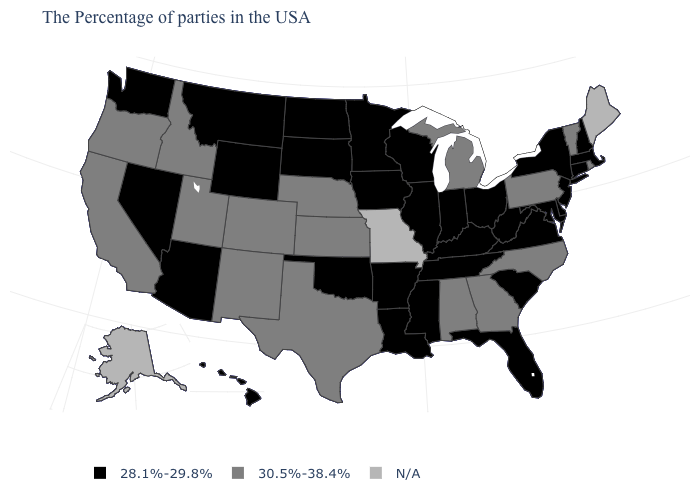What is the value of New York?
Keep it brief. 28.1%-29.8%. What is the value of Mississippi?
Short answer required. 28.1%-29.8%. Name the states that have a value in the range 28.1%-29.8%?
Answer briefly. Massachusetts, New Hampshire, Connecticut, New York, New Jersey, Delaware, Maryland, Virginia, South Carolina, West Virginia, Ohio, Florida, Kentucky, Indiana, Tennessee, Wisconsin, Illinois, Mississippi, Louisiana, Arkansas, Minnesota, Iowa, Oklahoma, South Dakota, North Dakota, Wyoming, Montana, Arizona, Nevada, Washington, Hawaii. Does the first symbol in the legend represent the smallest category?
Keep it brief. Yes. What is the value of Massachusetts?
Keep it brief. 28.1%-29.8%. Which states have the lowest value in the USA?
Write a very short answer. Massachusetts, New Hampshire, Connecticut, New York, New Jersey, Delaware, Maryland, Virginia, South Carolina, West Virginia, Ohio, Florida, Kentucky, Indiana, Tennessee, Wisconsin, Illinois, Mississippi, Louisiana, Arkansas, Minnesota, Iowa, Oklahoma, South Dakota, North Dakota, Wyoming, Montana, Arizona, Nevada, Washington, Hawaii. What is the value of Hawaii?
Quick response, please. 28.1%-29.8%. How many symbols are there in the legend?
Answer briefly. 3. Name the states that have a value in the range 30.5%-38.4%?
Concise answer only. Rhode Island, Vermont, Pennsylvania, North Carolina, Georgia, Michigan, Alabama, Kansas, Nebraska, Texas, Colorado, New Mexico, Utah, Idaho, California, Oregon. Name the states that have a value in the range 28.1%-29.8%?
Answer briefly. Massachusetts, New Hampshire, Connecticut, New York, New Jersey, Delaware, Maryland, Virginia, South Carolina, West Virginia, Ohio, Florida, Kentucky, Indiana, Tennessee, Wisconsin, Illinois, Mississippi, Louisiana, Arkansas, Minnesota, Iowa, Oklahoma, South Dakota, North Dakota, Wyoming, Montana, Arizona, Nevada, Washington, Hawaii. What is the value of Pennsylvania?
Concise answer only. 30.5%-38.4%. Which states have the highest value in the USA?
Write a very short answer. Rhode Island, Vermont, Pennsylvania, North Carolina, Georgia, Michigan, Alabama, Kansas, Nebraska, Texas, Colorado, New Mexico, Utah, Idaho, California, Oregon. Name the states that have a value in the range 28.1%-29.8%?
Quick response, please. Massachusetts, New Hampshire, Connecticut, New York, New Jersey, Delaware, Maryland, Virginia, South Carolina, West Virginia, Ohio, Florida, Kentucky, Indiana, Tennessee, Wisconsin, Illinois, Mississippi, Louisiana, Arkansas, Minnesota, Iowa, Oklahoma, South Dakota, North Dakota, Wyoming, Montana, Arizona, Nevada, Washington, Hawaii. What is the lowest value in states that border Montana?
Be succinct. 28.1%-29.8%. 